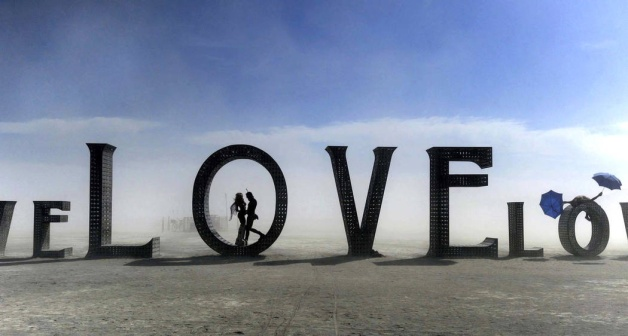What do you see happening in this image?
 In the vast expanse of a desert-like setting, a couple finds solace in each other's arms, their bodies forming a silhouette against the backdrop of a monumental sculpture spelling out the word "LOVE". The sculpture, crafted from stacked wooden crates, stands tall and imposing, its rustic texture contrasting with the smooth, sandy terrain. The couple is positioned perfectly within the hollow of the "O", their forms mirrored by the "V" to their right. 

In the distance, a lone figure ambles towards the right of the frame, a solitary umbrella held aloft providing a stark contrast to the couple's shared intimacy. The sky above is a canvas of hazy blue, its tranquility undisturbed by the drama unfolding below. Despite the barren surroundings, the image is a testament to the enduring power of love and companionship. 